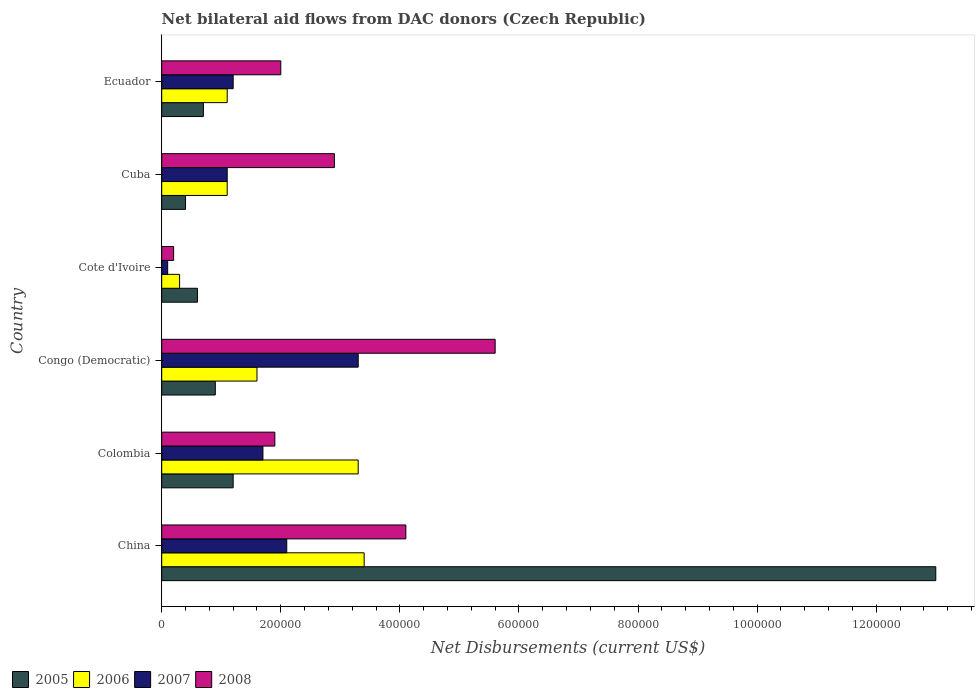How many different coloured bars are there?
Offer a very short reply. 4. How many groups of bars are there?
Your answer should be compact. 6. Are the number of bars per tick equal to the number of legend labels?
Ensure brevity in your answer.  Yes. What is the label of the 5th group of bars from the top?
Your answer should be compact. Colombia. In how many cases, is the number of bars for a given country not equal to the number of legend labels?
Provide a short and direct response. 0. Across all countries, what is the maximum net bilateral aid flows in 2005?
Keep it short and to the point. 1.30e+06. Across all countries, what is the minimum net bilateral aid flows in 2007?
Give a very brief answer. 10000. In which country was the net bilateral aid flows in 2008 maximum?
Keep it short and to the point. Congo (Democratic). In which country was the net bilateral aid flows in 2008 minimum?
Provide a short and direct response. Cote d'Ivoire. What is the total net bilateral aid flows in 2007 in the graph?
Your answer should be very brief. 9.50e+05. What is the difference between the net bilateral aid flows in 2007 in Cuba and the net bilateral aid flows in 2006 in Cote d'Ivoire?
Offer a terse response. 8.00e+04. What is the average net bilateral aid flows in 2005 per country?
Your response must be concise. 2.80e+05. What is the ratio of the net bilateral aid flows in 2005 in China to that in Colombia?
Give a very brief answer. 10.83. What is the difference between the highest and the lowest net bilateral aid flows in 2006?
Ensure brevity in your answer.  3.10e+05. In how many countries, is the net bilateral aid flows in 2006 greater than the average net bilateral aid flows in 2006 taken over all countries?
Your answer should be compact. 2. Is the sum of the net bilateral aid flows in 2007 in Cuba and Ecuador greater than the maximum net bilateral aid flows in 2005 across all countries?
Provide a short and direct response. No. Is it the case that in every country, the sum of the net bilateral aid flows in 2006 and net bilateral aid flows in 2008 is greater than the sum of net bilateral aid flows in 2007 and net bilateral aid flows in 2005?
Your answer should be compact. No. What does the 1st bar from the top in China represents?
Ensure brevity in your answer.  2008. What does the 2nd bar from the bottom in China represents?
Your response must be concise. 2006. How many bars are there?
Provide a short and direct response. 24. Are all the bars in the graph horizontal?
Provide a succinct answer. Yes. How many countries are there in the graph?
Make the answer very short. 6. Are the values on the major ticks of X-axis written in scientific E-notation?
Give a very brief answer. No. Does the graph contain any zero values?
Your answer should be very brief. No. Where does the legend appear in the graph?
Make the answer very short. Bottom left. How many legend labels are there?
Ensure brevity in your answer.  4. What is the title of the graph?
Your answer should be very brief. Net bilateral aid flows from DAC donors (Czech Republic). What is the label or title of the X-axis?
Provide a short and direct response. Net Disbursements (current US$). What is the Net Disbursements (current US$) in 2005 in China?
Provide a short and direct response. 1.30e+06. What is the Net Disbursements (current US$) of 2007 in China?
Make the answer very short. 2.10e+05. What is the Net Disbursements (current US$) in 2008 in China?
Offer a very short reply. 4.10e+05. What is the Net Disbursements (current US$) in 2007 in Colombia?
Your answer should be compact. 1.70e+05. What is the Net Disbursements (current US$) in 2008 in Colombia?
Ensure brevity in your answer.  1.90e+05. What is the Net Disbursements (current US$) in 2005 in Congo (Democratic)?
Give a very brief answer. 9.00e+04. What is the Net Disbursements (current US$) in 2008 in Congo (Democratic)?
Your answer should be very brief. 5.60e+05. What is the Net Disbursements (current US$) in 2006 in Cote d'Ivoire?
Give a very brief answer. 3.00e+04. What is the Net Disbursements (current US$) in 2007 in Cote d'Ivoire?
Your answer should be very brief. 10000. What is the Net Disbursements (current US$) of 2005 in Cuba?
Offer a terse response. 4.00e+04. What is the Net Disbursements (current US$) in 2007 in Cuba?
Give a very brief answer. 1.10e+05. What is the Net Disbursements (current US$) of 2005 in Ecuador?
Give a very brief answer. 7.00e+04. What is the Net Disbursements (current US$) in 2006 in Ecuador?
Your answer should be very brief. 1.10e+05. What is the Net Disbursements (current US$) of 2007 in Ecuador?
Keep it short and to the point. 1.20e+05. What is the Net Disbursements (current US$) in 2008 in Ecuador?
Provide a short and direct response. 2.00e+05. Across all countries, what is the maximum Net Disbursements (current US$) in 2005?
Your answer should be very brief. 1.30e+06. Across all countries, what is the maximum Net Disbursements (current US$) of 2006?
Provide a short and direct response. 3.40e+05. Across all countries, what is the maximum Net Disbursements (current US$) in 2007?
Your response must be concise. 3.30e+05. Across all countries, what is the maximum Net Disbursements (current US$) in 2008?
Your response must be concise. 5.60e+05. Across all countries, what is the minimum Net Disbursements (current US$) of 2007?
Your answer should be very brief. 10000. Across all countries, what is the minimum Net Disbursements (current US$) of 2008?
Make the answer very short. 2.00e+04. What is the total Net Disbursements (current US$) in 2005 in the graph?
Ensure brevity in your answer.  1.68e+06. What is the total Net Disbursements (current US$) in 2006 in the graph?
Ensure brevity in your answer.  1.08e+06. What is the total Net Disbursements (current US$) of 2007 in the graph?
Your answer should be very brief. 9.50e+05. What is the total Net Disbursements (current US$) in 2008 in the graph?
Your answer should be compact. 1.67e+06. What is the difference between the Net Disbursements (current US$) in 2005 in China and that in Colombia?
Offer a terse response. 1.18e+06. What is the difference between the Net Disbursements (current US$) of 2006 in China and that in Colombia?
Offer a very short reply. 10000. What is the difference between the Net Disbursements (current US$) in 2008 in China and that in Colombia?
Provide a succinct answer. 2.20e+05. What is the difference between the Net Disbursements (current US$) in 2005 in China and that in Congo (Democratic)?
Give a very brief answer. 1.21e+06. What is the difference between the Net Disbursements (current US$) in 2005 in China and that in Cote d'Ivoire?
Give a very brief answer. 1.24e+06. What is the difference between the Net Disbursements (current US$) of 2008 in China and that in Cote d'Ivoire?
Offer a very short reply. 3.90e+05. What is the difference between the Net Disbursements (current US$) in 2005 in China and that in Cuba?
Your response must be concise. 1.26e+06. What is the difference between the Net Disbursements (current US$) in 2007 in China and that in Cuba?
Offer a very short reply. 1.00e+05. What is the difference between the Net Disbursements (current US$) in 2008 in China and that in Cuba?
Offer a terse response. 1.20e+05. What is the difference between the Net Disbursements (current US$) in 2005 in China and that in Ecuador?
Your response must be concise. 1.23e+06. What is the difference between the Net Disbursements (current US$) of 2008 in China and that in Ecuador?
Make the answer very short. 2.10e+05. What is the difference between the Net Disbursements (current US$) in 2005 in Colombia and that in Congo (Democratic)?
Provide a short and direct response. 3.00e+04. What is the difference between the Net Disbursements (current US$) of 2006 in Colombia and that in Congo (Democratic)?
Ensure brevity in your answer.  1.70e+05. What is the difference between the Net Disbursements (current US$) of 2008 in Colombia and that in Congo (Democratic)?
Offer a very short reply. -3.70e+05. What is the difference between the Net Disbursements (current US$) of 2006 in Colombia and that in Cote d'Ivoire?
Offer a very short reply. 3.00e+05. What is the difference between the Net Disbursements (current US$) in 2007 in Colombia and that in Cote d'Ivoire?
Make the answer very short. 1.60e+05. What is the difference between the Net Disbursements (current US$) in 2008 in Colombia and that in Cote d'Ivoire?
Provide a succinct answer. 1.70e+05. What is the difference between the Net Disbursements (current US$) in 2006 in Colombia and that in Cuba?
Offer a very short reply. 2.20e+05. What is the difference between the Net Disbursements (current US$) of 2007 in Colombia and that in Cuba?
Give a very brief answer. 6.00e+04. What is the difference between the Net Disbursements (current US$) of 2008 in Colombia and that in Cuba?
Keep it short and to the point. -1.00e+05. What is the difference between the Net Disbursements (current US$) in 2006 in Colombia and that in Ecuador?
Keep it short and to the point. 2.20e+05. What is the difference between the Net Disbursements (current US$) of 2008 in Colombia and that in Ecuador?
Offer a very short reply. -10000. What is the difference between the Net Disbursements (current US$) in 2006 in Congo (Democratic) and that in Cote d'Ivoire?
Provide a succinct answer. 1.30e+05. What is the difference between the Net Disbursements (current US$) in 2007 in Congo (Democratic) and that in Cote d'Ivoire?
Make the answer very short. 3.20e+05. What is the difference between the Net Disbursements (current US$) of 2008 in Congo (Democratic) and that in Cote d'Ivoire?
Offer a terse response. 5.40e+05. What is the difference between the Net Disbursements (current US$) of 2005 in Congo (Democratic) and that in Cuba?
Offer a terse response. 5.00e+04. What is the difference between the Net Disbursements (current US$) of 2006 in Congo (Democratic) and that in Cuba?
Ensure brevity in your answer.  5.00e+04. What is the difference between the Net Disbursements (current US$) of 2006 in Congo (Democratic) and that in Ecuador?
Your answer should be compact. 5.00e+04. What is the difference between the Net Disbursements (current US$) in 2007 in Congo (Democratic) and that in Ecuador?
Provide a short and direct response. 2.10e+05. What is the difference between the Net Disbursements (current US$) of 2006 in Cote d'Ivoire and that in Cuba?
Keep it short and to the point. -8.00e+04. What is the difference between the Net Disbursements (current US$) in 2007 in Cote d'Ivoire and that in Cuba?
Your answer should be very brief. -1.00e+05. What is the difference between the Net Disbursements (current US$) of 2005 in Cote d'Ivoire and that in Ecuador?
Your answer should be compact. -10000. What is the difference between the Net Disbursements (current US$) in 2007 in Cote d'Ivoire and that in Ecuador?
Make the answer very short. -1.10e+05. What is the difference between the Net Disbursements (current US$) in 2008 in Cote d'Ivoire and that in Ecuador?
Offer a terse response. -1.80e+05. What is the difference between the Net Disbursements (current US$) in 2006 in Cuba and that in Ecuador?
Make the answer very short. 0. What is the difference between the Net Disbursements (current US$) of 2005 in China and the Net Disbursements (current US$) of 2006 in Colombia?
Provide a succinct answer. 9.70e+05. What is the difference between the Net Disbursements (current US$) in 2005 in China and the Net Disbursements (current US$) in 2007 in Colombia?
Offer a terse response. 1.13e+06. What is the difference between the Net Disbursements (current US$) of 2005 in China and the Net Disbursements (current US$) of 2008 in Colombia?
Make the answer very short. 1.11e+06. What is the difference between the Net Disbursements (current US$) of 2006 in China and the Net Disbursements (current US$) of 2007 in Colombia?
Make the answer very short. 1.70e+05. What is the difference between the Net Disbursements (current US$) in 2006 in China and the Net Disbursements (current US$) in 2008 in Colombia?
Provide a short and direct response. 1.50e+05. What is the difference between the Net Disbursements (current US$) in 2005 in China and the Net Disbursements (current US$) in 2006 in Congo (Democratic)?
Make the answer very short. 1.14e+06. What is the difference between the Net Disbursements (current US$) of 2005 in China and the Net Disbursements (current US$) of 2007 in Congo (Democratic)?
Keep it short and to the point. 9.70e+05. What is the difference between the Net Disbursements (current US$) in 2005 in China and the Net Disbursements (current US$) in 2008 in Congo (Democratic)?
Offer a terse response. 7.40e+05. What is the difference between the Net Disbursements (current US$) of 2006 in China and the Net Disbursements (current US$) of 2008 in Congo (Democratic)?
Provide a succinct answer. -2.20e+05. What is the difference between the Net Disbursements (current US$) in 2007 in China and the Net Disbursements (current US$) in 2008 in Congo (Democratic)?
Your answer should be compact. -3.50e+05. What is the difference between the Net Disbursements (current US$) of 2005 in China and the Net Disbursements (current US$) of 2006 in Cote d'Ivoire?
Provide a short and direct response. 1.27e+06. What is the difference between the Net Disbursements (current US$) of 2005 in China and the Net Disbursements (current US$) of 2007 in Cote d'Ivoire?
Your answer should be very brief. 1.29e+06. What is the difference between the Net Disbursements (current US$) of 2005 in China and the Net Disbursements (current US$) of 2008 in Cote d'Ivoire?
Ensure brevity in your answer.  1.28e+06. What is the difference between the Net Disbursements (current US$) in 2006 in China and the Net Disbursements (current US$) in 2007 in Cote d'Ivoire?
Offer a terse response. 3.30e+05. What is the difference between the Net Disbursements (current US$) in 2005 in China and the Net Disbursements (current US$) in 2006 in Cuba?
Give a very brief answer. 1.19e+06. What is the difference between the Net Disbursements (current US$) of 2005 in China and the Net Disbursements (current US$) of 2007 in Cuba?
Provide a short and direct response. 1.19e+06. What is the difference between the Net Disbursements (current US$) of 2005 in China and the Net Disbursements (current US$) of 2008 in Cuba?
Give a very brief answer. 1.01e+06. What is the difference between the Net Disbursements (current US$) in 2006 in China and the Net Disbursements (current US$) in 2008 in Cuba?
Offer a very short reply. 5.00e+04. What is the difference between the Net Disbursements (current US$) of 2007 in China and the Net Disbursements (current US$) of 2008 in Cuba?
Offer a very short reply. -8.00e+04. What is the difference between the Net Disbursements (current US$) of 2005 in China and the Net Disbursements (current US$) of 2006 in Ecuador?
Provide a succinct answer. 1.19e+06. What is the difference between the Net Disbursements (current US$) in 2005 in China and the Net Disbursements (current US$) in 2007 in Ecuador?
Your answer should be compact. 1.18e+06. What is the difference between the Net Disbursements (current US$) of 2005 in China and the Net Disbursements (current US$) of 2008 in Ecuador?
Provide a short and direct response. 1.10e+06. What is the difference between the Net Disbursements (current US$) of 2006 in China and the Net Disbursements (current US$) of 2007 in Ecuador?
Provide a succinct answer. 2.20e+05. What is the difference between the Net Disbursements (current US$) of 2007 in China and the Net Disbursements (current US$) of 2008 in Ecuador?
Provide a short and direct response. 10000. What is the difference between the Net Disbursements (current US$) of 2005 in Colombia and the Net Disbursements (current US$) of 2007 in Congo (Democratic)?
Your answer should be compact. -2.10e+05. What is the difference between the Net Disbursements (current US$) of 2005 in Colombia and the Net Disbursements (current US$) of 2008 in Congo (Democratic)?
Offer a very short reply. -4.40e+05. What is the difference between the Net Disbursements (current US$) of 2006 in Colombia and the Net Disbursements (current US$) of 2008 in Congo (Democratic)?
Your answer should be very brief. -2.30e+05. What is the difference between the Net Disbursements (current US$) in 2007 in Colombia and the Net Disbursements (current US$) in 2008 in Congo (Democratic)?
Give a very brief answer. -3.90e+05. What is the difference between the Net Disbursements (current US$) in 2005 in Colombia and the Net Disbursements (current US$) in 2006 in Cote d'Ivoire?
Offer a terse response. 9.00e+04. What is the difference between the Net Disbursements (current US$) of 2005 in Colombia and the Net Disbursements (current US$) of 2007 in Cote d'Ivoire?
Your answer should be very brief. 1.10e+05. What is the difference between the Net Disbursements (current US$) of 2006 in Colombia and the Net Disbursements (current US$) of 2007 in Cote d'Ivoire?
Offer a very short reply. 3.20e+05. What is the difference between the Net Disbursements (current US$) of 2007 in Colombia and the Net Disbursements (current US$) of 2008 in Cote d'Ivoire?
Your answer should be compact. 1.50e+05. What is the difference between the Net Disbursements (current US$) of 2005 in Colombia and the Net Disbursements (current US$) of 2006 in Cuba?
Offer a very short reply. 10000. What is the difference between the Net Disbursements (current US$) of 2006 in Colombia and the Net Disbursements (current US$) of 2008 in Cuba?
Provide a short and direct response. 4.00e+04. What is the difference between the Net Disbursements (current US$) in 2007 in Colombia and the Net Disbursements (current US$) in 2008 in Cuba?
Ensure brevity in your answer.  -1.20e+05. What is the difference between the Net Disbursements (current US$) of 2005 in Colombia and the Net Disbursements (current US$) of 2006 in Ecuador?
Provide a short and direct response. 10000. What is the difference between the Net Disbursements (current US$) in 2006 in Colombia and the Net Disbursements (current US$) in 2007 in Ecuador?
Provide a short and direct response. 2.10e+05. What is the difference between the Net Disbursements (current US$) of 2005 in Congo (Democratic) and the Net Disbursements (current US$) of 2006 in Cuba?
Offer a terse response. -2.00e+04. What is the difference between the Net Disbursements (current US$) in 2005 in Congo (Democratic) and the Net Disbursements (current US$) in 2008 in Cuba?
Offer a terse response. -2.00e+05. What is the difference between the Net Disbursements (current US$) of 2007 in Congo (Democratic) and the Net Disbursements (current US$) of 2008 in Cuba?
Your answer should be compact. 4.00e+04. What is the difference between the Net Disbursements (current US$) in 2005 in Congo (Democratic) and the Net Disbursements (current US$) in 2006 in Ecuador?
Make the answer very short. -2.00e+04. What is the difference between the Net Disbursements (current US$) of 2005 in Congo (Democratic) and the Net Disbursements (current US$) of 2007 in Ecuador?
Keep it short and to the point. -3.00e+04. What is the difference between the Net Disbursements (current US$) of 2005 in Congo (Democratic) and the Net Disbursements (current US$) of 2008 in Ecuador?
Give a very brief answer. -1.10e+05. What is the difference between the Net Disbursements (current US$) in 2006 in Congo (Democratic) and the Net Disbursements (current US$) in 2007 in Ecuador?
Your answer should be compact. 4.00e+04. What is the difference between the Net Disbursements (current US$) in 2005 in Cote d'Ivoire and the Net Disbursements (current US$) in 2007 in Cuba?
Make the answer very short. -5.00e+04. What is the difference between the Net Disbursements (current US$) of 2005 in Cote d'Ivoire and the Net Disbursements (current US$) of 2008 in Cuba?
Offer a very short reply. -2.30e+05. What is the difference between the Net Disbursements (current US$) of 2006 in Cote d'Ivoire and the Net Disbursements (current US$) of 2007 in Cuba?
Your answer should be compact. -8.00e+04. What is the difference between the Net Disbursements (current US$) of 2006 in Cote d'Ivoire and the Net Disbursements (current US$) of 2008 in Cuba?
Make the answer very short. -2.60e+05. What is the difference between the Net Disbursements (current US$) of 2007 in Cote d'Ivoire and the Net Disbursements (current US$) of 2008 in Cuba?
Your answer should be very brief. -2.80e+05. What is the difference between the Net Disbursements (current US$) in 2005 in Cote d'Ivoire and the Net Disbursements (current US$) in 2006 in Ecuador?
Your answer should be compact. -5.00e+04. What is the difference between the Net Disbursements (current US$) of 2005 in Cote d'Ivoire and the Net Disbursements (current US$) of 2007 in Ecuador?
Provide a succinct answer. -6.00e+04. What is the difference between the Net Disbursements (current US$) of 2005 in Cote d'Ivoire and the Net Disbursements (current US$) of 2008 in Ecuador?
Make the answer very short. -1.40e+05. What is the difference between the Net Disbursements (current US$) in 2006 in Cote d'Ivoire and the Net Disbursements (current US$) in 2007 in Ecuador?
Provide a succinct answer. -9.00e+04. What is the difference between the Net Disbursements (current US$) in 2005 in Cuba and the Net Disbursements (current US$) in 2007 in Ecuador?
Ensure brevity in your answer.  -8.00e+04. What is the difference between the Net Disbursements (current US$) of 2006 in Cuba and the Net Disbursements (current US$) of 2008 in Ecuador?
Ensure brevity in your answer.  -9.00e+04. What is the average Net Disbursements (current US$) of 2005 per country?
Your answer should be very brief. 2.80e+05. What is the average Net Disbursements (current US$) in 2006 per country?
Provide a short and direct response. 1.80e+05. What is the average Net Disbursements (current US$) of 2007 per country?
Provide a succinct answer. 1.58e+05. What is the average Net Disbursements (current US$) in 2008 per country?
Make the answer very short. 2.78e+05. What is the difference between the Net Disbursements (current US$) of 2005 and Net Disbursements (current US$) of 2006 in China?
Keep it short and to the point. 9.60e+05. What is the difference between the Net Disbursements (current US$) in 2005 and Net Disbursements (current US$) in 2007 in China?
Your answer should be compact. 1.09e+06. What is the difference between the Net Disbursements (current US$) of 2005 and Net Disbursements (current US$) of 2008 in China?
Ensure brevity in your answer.  8.90e+05. What is the difference between the Net Disbursements (current US$) of 2006 and Net Disbursements (current US$) of 2007 in China?
Your answer should be compact. 1.30e+05. What is the difference between the Net Disbursements (current US$) in 2006 and Net Disbursements (current US$) in 2008 in China?
Keep it short and to the point. -7.00e+04. What is the difference between the Net Disbursements (current US$) of 2007 and Net Disbursements (current US$) of 2008 in China?
Your answer should be compact. -2.00e+05. What is the difference between the Net Disbursements (current US$) of 2005 and Net Disbursements (current US$) of 2006 in Colombia?
Your response must be concise. -2.10e+05. What is the difference between the Net Disbursements (current US$) of 2005 and Net Disbursements (current US$) of 2008 in Colombia?
Ensure brevity in your answer.  -7.00e+04. What is the difference between the Net Disbursements (current US$) of 2006 and Net Disbursements (current US$) of 2008 in Colombia?
Offer a terse response. 1.40e+05. What is the difference between the Net Disbursements (current US$) in 2007 and Net Disbursements (current US$) in 2008 in Colombia?
Provide a succinct answer. -2.00e+04. What is the difference between the Net Disbursements (current US$) of 2005 and Net Disbursements (current US$) of 2006 in Congo (Democratic)?
Make the answer very short. -7.00e+04. What is the difference between the Net Disbursements (current US$) of 2005 and Net Disbursements (current US$) of 2007 in Congo (Democratic)?
Make the answer very short. -2.40e+05. What is the difference between the Net Disbursements (current US$) in 2005 and Net Disbursements (current US$) in 2008 in Congo (Democratic)?
Keep it short and to the point. -4.70e+05. What is the difference between the Net Disbursements (current US$) of 2006 and Net Disbursements (current US$) of 2007 in Congo (Democratic)?
Your answer should be compact. -1.70e+05. What is the difference between the Net Disbursements (current US$) in 2006 and Net Disbursements (current US$) in 2008 in Congo (Democratic)?
Your answer should be compact. -4.00e+05. What is the difference between the Net Disbursements (current US$) of 2005 and Net Disbursements (current US$) of 2007 in Cote d'Ivoire?
Provide a short and direct response. 5.00e+04. What is the difference between the Net Disbursements (current US$) of 2006 and Net Disbursements (current US$) of 2007 in Cote d'Ivoire?
Your response must be concise. 2.00e+04. What is the difference between the Net Disbursements (current US$) of 2007 and Net Disbursements (current US$) of 2008 in Cote d'Ivoire?
Your response must be concise. -10000. What is the difference between the Net Disbursements (current US$) of 2005 and Net Disbursements (current US$) of 2006 in Cuba?
Give a very brief answer. -7.00e+04. What is the difference between the Net Disbursements (current US$) of 2005 and Net Disbursements (current US$) of 2007 in Cuba?
Ensure brevity in your answer.  -7.00e+04. What is the difference between the Net Disbursements (current US$) in 2005 and Net Disbursements (current US$) in 2008 in Cuba?
Your response must be concise. -2.50e+05. What is the difference between the Net Disbursements (current US$) of 2005 and Net Disbursements (current US$) of 2006 in Ecuador?
Your answer should be compact. -4.00e+04. What is the ratio of the Net Disbursements (current US$) in 2005 in China to that in Colombia?
Keep it short and to the point. 10.83. What is the ratio of the Net Disbursements (current US$) of 2006 in China to that in Colombia?
Give a very brief answer. 1.03. What is the ratio of the Net Disbursements (current US$) in 2007 in China to that in Colombia?
Make the answer very short. 1.24. What is the ratio of the Net Disbursements (current US$) in 2008 in China to that in Colombia?
Make the answer very short. 2.16. What is the ratio of the Net Disbursements (current US$) of 2005 in China to that in Congo (Democratic)?
Offer a very short reply. 14.44. What is the ratio of the Net Disbursements (current US$) in 2006 in China to that in Congo (Democratic)?
Ensure brevity in your answer.  2.12. What is the ratio of the Net Disbursements (current US$) of 2007 in China to that in Congo (Democratic)?
Give a very brief answer. 0.64. What is the ratio of the Net Disbursements (current US$) in 2008 in China to that in Congo (Democratic)?
Your response must be concise. 0.73. What is the ratio of the Net Disbursements (current US$) in 2005 in China to that in Cote d'Ivoire?
Your response must be concise. 21.67. What is the ratio of the Net Disbursements (current US$) of 2006 in China to that in Cote d'Ivoire?
Your answer should be compact. 11.33. What is the ratio of the Net Disbursements (current US$) in 2007 in China to that in Cote d'Ivoire?
Provide a short and direct response. 21. What is the ratio of the Net Disbursements (current US$) in 2008 in China to that in Cote d'Ivoire?
Make the answer very short. 20.5. What is the ratio of the Net Disbursements (current US$) of 2005 in China to that in Cuba?
Your response must be concise. 32.5. What is the ratio of the Net Disbursements (current US$) of 2006 in China to that in Cuba?
Keep it short and to the point. 3.09. What is the ratio of the Net Disbursements (current US$) of 2007 in China to that in Cuba?
Provide a succinct answer. 1.91. What is the ratio of the Net Disbursements (current US$) of 2008 in China to that in Cuba?
Make the answer very short. 1.41. What is the ratio of the Net Disbursements (current US$) of 2005 in China to that in Ecuador?
Give a very brief answer. 18.57. What is the ratio of the Net Disbursements (current US$) in 2006 in China to that in Ecuador?
Give a very brief answer. 3.09. What is the ratio of the Net Disbursements (current US$) in 2007 in China to that in Ecuador?
Provide a short and direct response. 1.75. What is the ratio of the Net Disbursements (current US$) of 2008 in China to that in Ecuador?
Keep it short and to the point. 2.05. What is the ratio of the Net Disbursements (current US$) of 2005 in Colombia to that in Congo (Democratic)?
Provide a succinct answer. 1.33. What is the ratio of the Net Disbursements (current US$) in 2006 in Colombia to that in Congo (Democratic)?
Give a very brief answer. 2.06. What is the ratio of the Net Disbursements (current US$) in 2007 in Colombia to that in Congo (Democratic)?
Ensure brevity in your answer.  0.52. What is the ratio of the Net Disbursements (current US$) in 2008 in Colombia to that in Congo (Democratic)?
Give a very brief answer. 0.34. What is the ratio of the Net Disbursements (current US$) of 2007 in Colombia to that in Cuba?
Your response must be concise. 1.55. What is the ratio of the Net Disbursements (current US$) of 2008 in Colombia to that in Cuba?
Make the answer very short. 0.66. What is the ratio of the Net Disbursements (current US$) of 2005 in Colombia to that in Ecuador?
Provide a short and direct response. 1.71. What is the ratio of the Net Disbursements (current US$) of 2007 in Colombia to that in Ecuador?
Ensure brevity in your answer.  1.42. What is the ratio of the Net Disbursements (current US$) of 2005 in Congo (Democratic) to that in Cote d'Ivoire?
Ensure brevity in your answer.  1.5. What is the ratio of the Net Disbursements (current US$) of 2006 in Congo (Democratic) to that in Cote d'Ivoire?
Offer a terse response. 5.33. What is the ratio of the Net Disbursements (current US$) in 2007 in Congo (Democratic) to that in Cote d'Ivoire?
Give a very brief answer. 33. What is the ratio of the Net Disbursements (current US$) of 2005 in Congo (Democratic) to that in Cuba?
Give a very brief answer. 2.25. What is the ratio of the Net Disbursements (current US$) of 2006 in Congo (Democratic) to that in Cuba?
Offer a very short reply. 1.45. What is the ratio of the Net Disbursements (current US$) in 2007 in Congo (Democratic) to that in Cuba?
Provide a succinct answer. 3. What is the ratio of the Net Disbursements (current US$) of 2008 in Congo (Democratic) to that in Cuba?
Ensure brevity in your answer.  1.93. What is the ratio of the Net Disbursements (current US$) in 2006 in Congo (Democratic) to that in Ecuador?
Your answer should be very brief. 1.45. What is the ratio of the Net Disbursements (current US$) of 2007 in Congo (Democratic) to that in Ecuador?
Offer a terse response. 2.75. What is the ratio of the Net Disbursements (current US$) in 2005 in Cote d'Ivoire to that in Cuba?
Provide a short and direct response. 1.5. What is the ratio of the Net Disbursements (current US$) in 2006 in Cote d'Ivoire to that in Cuba?
Your answer should be very brief. 0.27. What is the ratio of the Net Disbursements (current US$) in 2007 in Cote d'Ivoire to that in Cuba?
Make the answer very short. 0.09. What is the ratio of the Net Disbursements (current US$) of 2008 in Cote d'Ivoire to that in Cuba?
Your response must be concise. 0.07. What is the ratio of the Net Disbursements (current US$) of 2005 in Cote d'Ivoire to that in Ecuador?
Offer a terse response. 0.86. What is the ratio of the Net Disbursements (current US$) in 2006 in Cote d'Ivoire to that in Ecuador?
Your response must be concise. 0.27. What is the ratio of the Net Disbursements (current US$) of 2007 in Cote d'Ivoire to that in Ecuador?
Your response must be concise. 0.08. What is the ratio of the Net Disbursements (current US$) of 2008 in Cote d'Ivoire to that in Ecuador?
Make the answer very short. 0.1. What is the ratio of the Net Disbursements (current US$) of 2006 in Cuba to that in Ecuador?
Your answer should be very brief. 1. What is the ratio of the Net Disbursements (current US$) in 2007 in Cuba to that in Ecuador?
Give a very brief answer. 0.92. What is the ratio of the Net Disbursements (current US$) in 2008 in Cuba to that in Ecuador?
Keep it short and to the point. 1.45. What is the difference between the highest and the second highest Net Disbursements (current US$) in 2005?
Give a very brief answer. 1.18e+06. What is the difference between the highest and the second highest Net Disbursements (current US$) in 2006?
Keep it short and to the point. 10000. What is the difference between the highest and the second highest Net Disbursements (current US$) of 2008?
Offer a very short reply. 1.50e+05. What is the difference between the highest and the lowest Net Disbursements (current US$) in 2005?
Provide a succinct answer. 1.26e+06. What is the difference between the highest and the lowest Net Disbursements (current US$) in 2006?
Keep it short and to the point. 3.10e+05. What is the difference between the highest and the lowest Net Disbursements (current US$) in 2007?
Ensure brevity in your answer.  3.20e+05. What is the difference between the highest and the lowest Net Disbursements (current US$) of 2008?
Make the answer very short. 5.40e+05. 